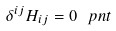<formula> <loc_0><loc_0><loc_500><loc_500>\delta ^ { i j } H _ { i j } = 0 \ p n t</formula> 